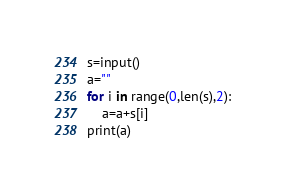Convert code to text. <code><loc_0><loc_0><loc_500><loc_500><_Python_>s=input()
a=""
for i in range(0,len(s),2):
    a=a+s[i]
print(a)    </code> 